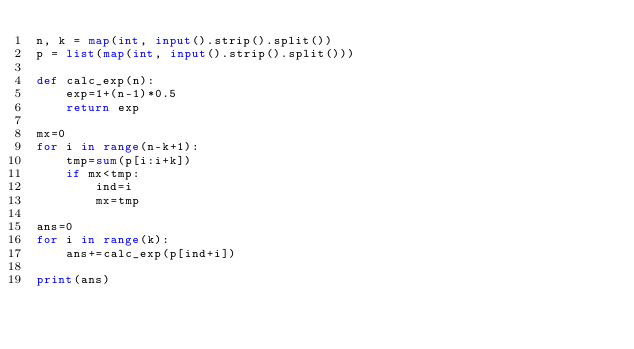<code> <loc_0><loc_0><loc_500><loc_500><_Python_>n, k = map(int, input().strip().split())
p = list(map(int, input().strip().split()))

def calc_exp(n):
    exp=1+(n-1)*0.5
    return exp

mx=0
for i in range(n-k+1):
    tmp=sum(p[i:i+k])
    if mx<tmp:
        ind=i
        mx=tmp
        
ans=0
for i in range(k):
    ans+=calc_exp(p[ind+i])
    
print(ans)
</code> 